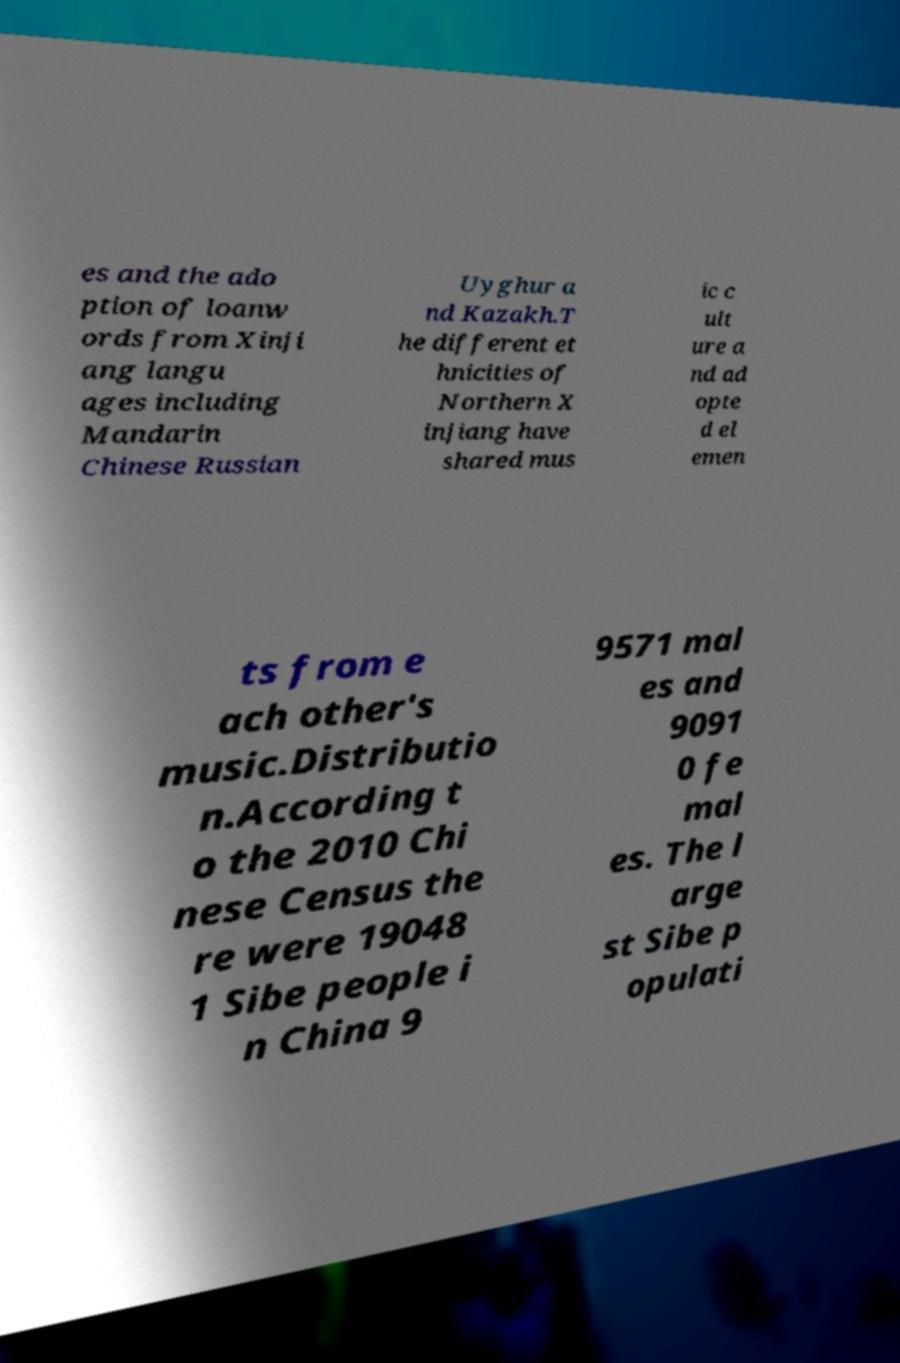For documentation purposes, I need the text within this image transcribed. Could you provide that? es and the ado ption of loanw ords from Xinji ang langu ages including Mandarin Chinese Russian Uyghur a nd Kazakh.T he different et hnicities of Northern X injiang have shared mus ic c ult ure a nd ad opte d el emen ts from e ach other's music.Distributio n.According t o the 2010 Chi nese Census the re were 19048 1 Sibe people i n China 9 9571 mal es and 9091 0 fe mal es. The l arge st Sibe p opulati 